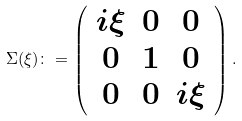Convert formula to latex. <formula><loc_0><loc_0><loc_500><loc_500>\Sigma ( \xi ) \colon = \left ( \begin{array} { c c c } i \xi & 0 & 0 \\ 0 & 1 & 0 \\ 0 & 0 & i \xi \end{array} \right ) .</formula> 